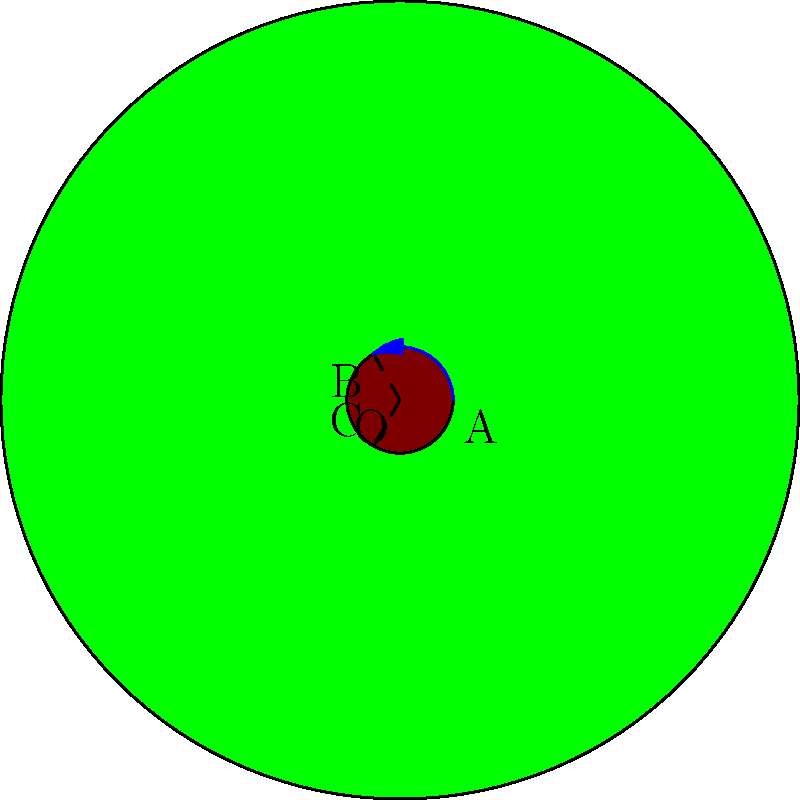A circular forest with radius 3 units has a small circular clearing at its center. The clearing is rotated 120° clockwise around the center point O to simulate different deforestation scenarios. If the initial position of a point on the edge of the clearing is at A, what are the coordinates of this point after two such rotations? Let's approach this step-by-step:

1) The initial position A is at (0.4, 0) in the given coordinate system.

2) A 120° clockwise rotation is equivalent to a 240° counterclockwise rotation.

3) The rotation matrix for a counterclockwise rotation by angle θ is:
   $$R(\theta) = \begin{pmatrix} \cos\theta & -\sin\theta \\ \sin\theta & \cos\theta \end{pmatrix}$$

4) For θ = 240°, we have:
   $$R(240°) = \begin{pmatrix} \cos240° & -\sin240° \\ \sin240° & \cos240° \end{pmatrix}$$

5) $\cos240° = -\frac{1}{2}$ and $\sin240° = -\frac{\sqrt{3}}{2}$

6) Therefore, the rotation matrix is:
   $$R(240°) = \begin{pmatrix} -\frac{1}{2} & \frac{\sqrt{3}}{2} \\ -\frac{\sqrt{3}}{2} & -\frac{1}{2} \end{pmatrix}$$

7) Applying this rotation twice to the point (0.4, 0):
   $$\begin{pmatrix} -\frac{1}{2} & \frac{\sqrt{3}}{2} \\ -\frac{\sqrt{3}}{2} & -\frac{1}{2} \end{pmatrix} \begin{pmatrix} -\frac{1}{2} & \frac{\sqrt{3}}{2} \\ -\frac{\sqrt{3}}{2} & -\frac{1}{2} \end{pmatrix} \begin{pmatrix} 0.4 \\ 0 \end{pmatrix}$$

8) Simplifying:
   $$\begin{pmatrix} -\frac{1}{2} & \frac{\sqrt{3}}{2} \\ -\frac{\sqrt{3}}{2} & -\frac{1}{2} \end{pmatrix} \begin{pmatrix} -0.2 \\ -0.2\sqrt{3} \end{pmatrix} = \begin{pmatrix} 0.2 \\ 0.2\sqrt{3} \end{pmatrix}$$

Therefore, after two rotations, the point A will be at (0.2, 0.2√3).
Answer: (0.2, 0.2√3) 